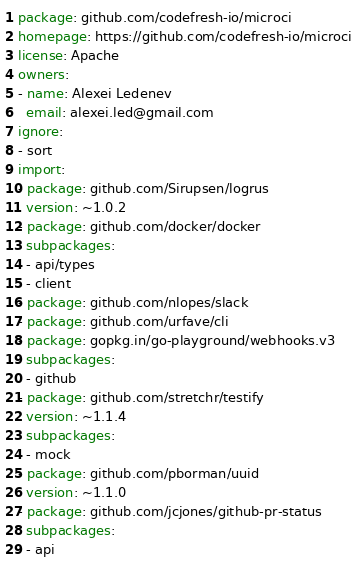Convert code to text. <code><loc_0><loc_0><loc_500><loc_500><_YAML_>package: github.com/codefresh-io/microci
homepage: https://github.com/codefresh-io/microci
license: Apache
owners:
- name: Alexei Ledenev
  email: alexei.led@gmail.com
ignore:
- sort
import:
- package: github.com/Sirupsen/logrus
  version: ~1.0.2
- package: github.com/docker/docker
  subpackages:
  - api/types
  - client
- package: github.com/nlopes/slack
- package: github.com/urfave/cli
- package: gopkg.in/go-playground/webhooks.v3
  subpackages:
  - github
- package: github.com/stretchr/testify
  version: ~1.1.4
  subpackages:
  - mock
- package: github.com/pborman/uuid
  version: ~1.1.0
- package: github.com/jcjones/github-pr-status
  subpackages:
  - api
</code> 